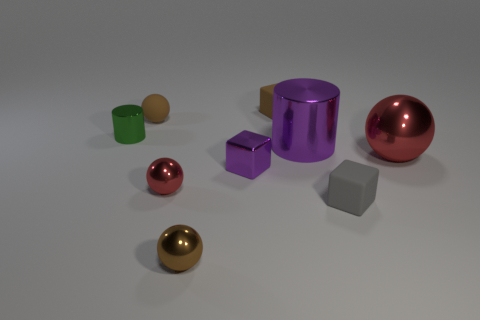Subtract all matte blocks. How many blocks are left? 1 Add 1 small red metal objects. How many objects exist? 10 Subtract all purple cubes. How many cubes are left? 2 Subtract 0 red cylinders. How many objects are left? 9 Subtract all blocks. How many objects are left? 6 Subtract 1 blocks. How many blocks are left? 2 Subtract all blue cylinders. Subtract all yellow balls. How many cylinders are left? 2 Subtract all gray cylinders. How many yellow blocks are left? 0 Subtract all small metallic cylinders. Subtract all small brown matte objects. How many objects are left? 6 Add 4 metallic cylinders. How many metallic cylinders are left? 6 